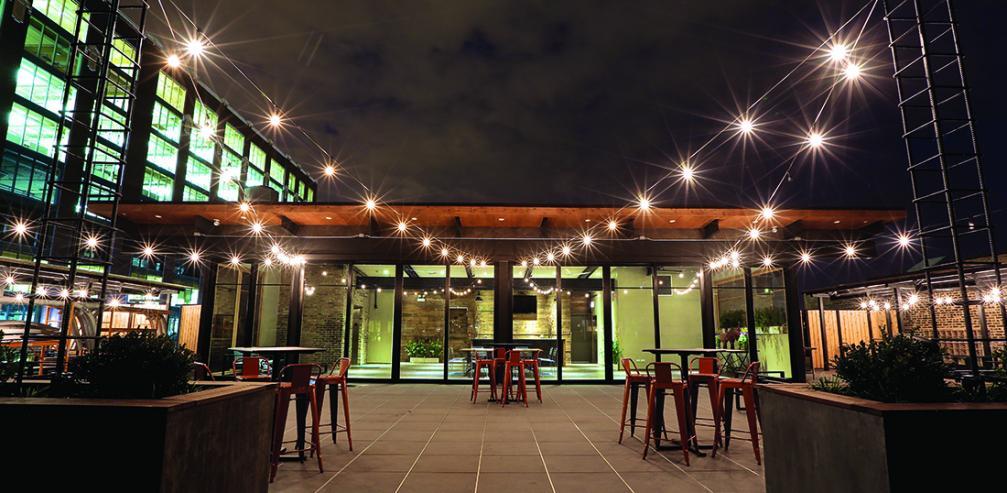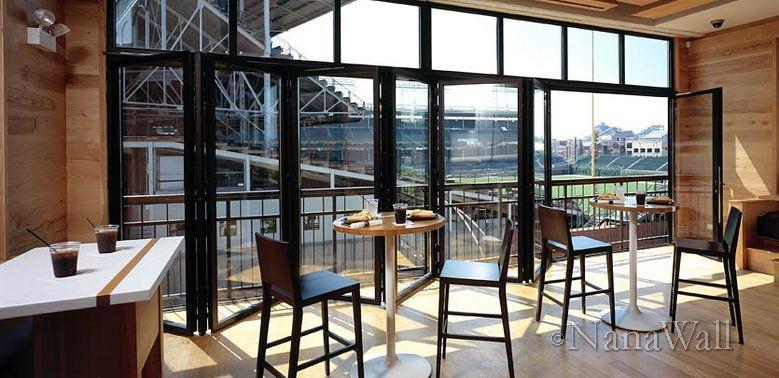The first image is the image on the left, the second image is the image on the right. For the images displayed, is the sentence "There is a five glass panel and black trim set of doors acorning." factually correct? Answer yes or no. Yes. The first image is the image on the left, the second image is the image on the right. Evaluate the accuracy of this statement regarding the images: "One image is inside and one is outside.". Is it true? Answer yes or no. Yes. 